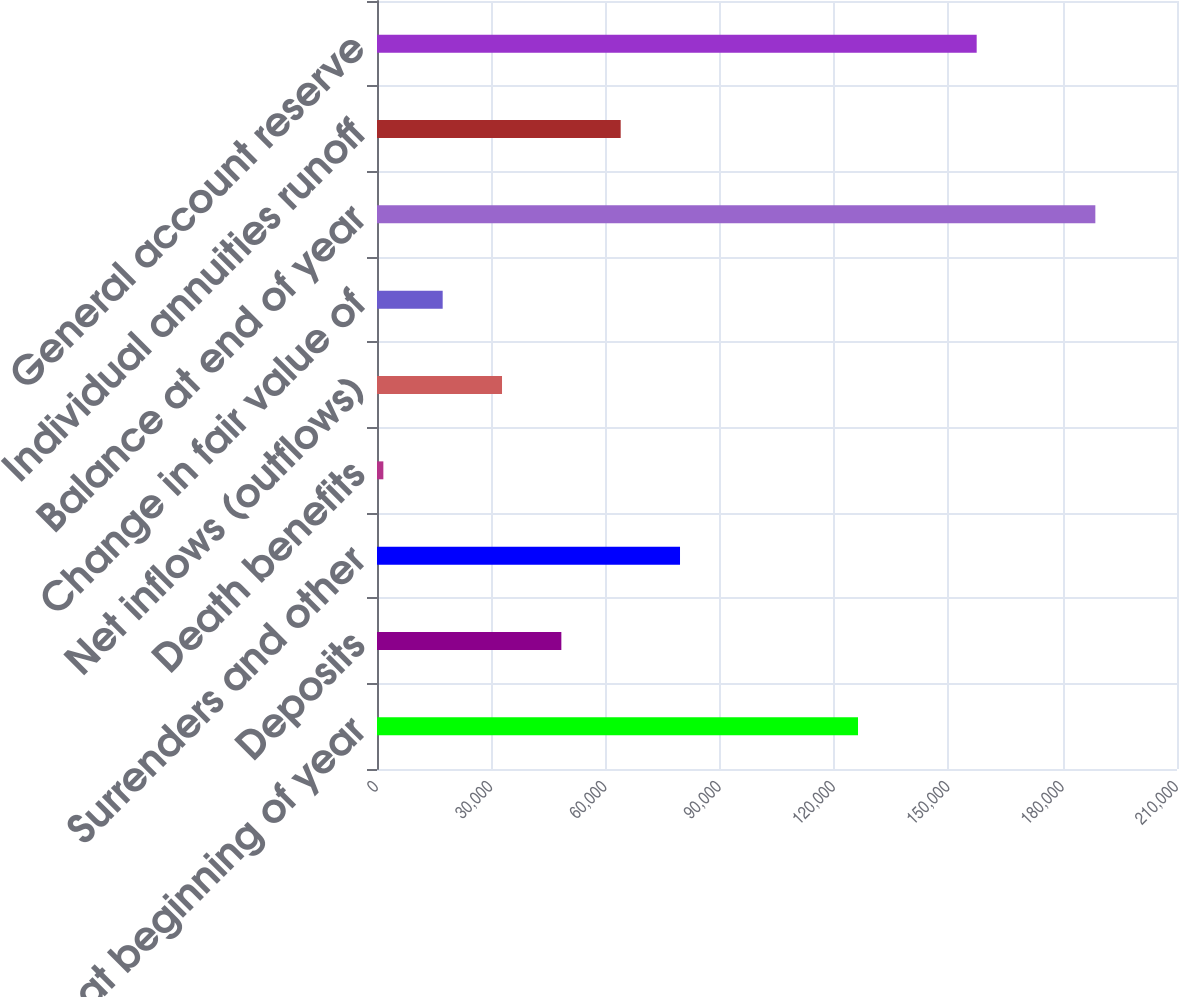Convert chart. <chart><loc_0><loc_0><loc_500><loc_500><bar_chart><fcel>Balance at beginning of year<fcel>Deposits<fcel>Surrenders and other<fcel>Death benefits<fcel>Net inflows (outflows)<fcel>Change in fair value of<fcel>Balance at end of year<fcel>Individual annuities runoff<fcel>General account reserve<nl><fcel>126265<fcel>48391.4<fcel>79541<fcel>1667<fcel>32816.6<fcel>17241.8<fcel>188565<fcel>63966.2<fcel>157415<nl></chart> 